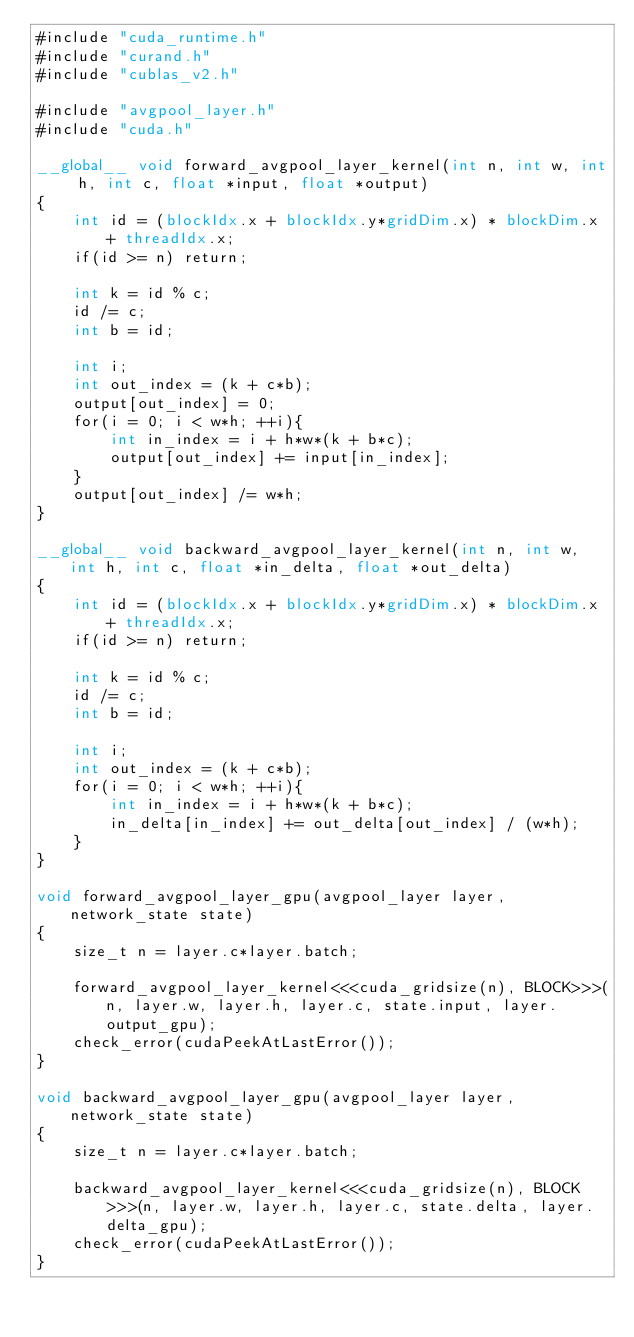Convert code to text. <code><loc_0><loc_0><loc_500><loc_500><_Cuda_>#include "cuda_runtime.h"
#include "curand.h"
#include "cublas_v2.h"

#include "avgpool_layer.h"
#include "cuda.h"

__global__ void forward_avgpool_layer_kernel(int n, int w, int h, int c, float *input, float *output)
{
    int id = (blockIdx.x + blockIdx.y*gridDim.x) * blockDim.x + threadIdx.x;
    if(id >= n) return;

    int k = id % c;
    id /= c;
    int b = id;

    int i;
    int out_index = (k + c*b);
    output[out_index] = 0;
    for(i = 0; i < w*h; ++i){
        int in_index = i + h*w*(k + b*c);
        output[out_index] += input[in_index];
    }
    output[out_index] /= w*h;
}

__global__ void backward_avgpool_layer_kernel(int n, int w, int h, int c, float *in_delta, float *out_delta)
{
    int id = (blockIdx.x + blockIdx.y*gridDim.x) * blockDim.x + threadIdx.x;
    if(id >= n) return;

    int k = id % c;
    id /= c;
    int b = id;

    int i;
    int out_index = (k + c*b);
    for(i = 0; i < w*h; ++i){
        int in_index = i + h*w*(k + b*c);
        in_delta[in_index] += out_delta[out_index] / (w*h);
    }
}

void forward_avgpool_layer_gpu(avgpool_layer layer, network_state state)
{
    size_t n = layer.c*layer.batch;

    forward_avgpool_layer_kernel<<<cuda_gridsize(n), BLOCK>>>(n, layer.w, layer.h, layer.c, state.input, layer.output_gpu);
    check_error(cudaPeekAtLastError());
}

void backward_avgpool_layer_gpu(avgpool_layer layer, network_state state)
{
    size_t n = layer.c*layer.batch;

    backward_avgpool_layer_kernel<<<cuda_gridsize(n), BLOCK>>>(n, layer.w, layer.h, layer.c, state.delta, layer.delta_gpu);
    check_error(cudaPeekAtLastError());
}

</code> 